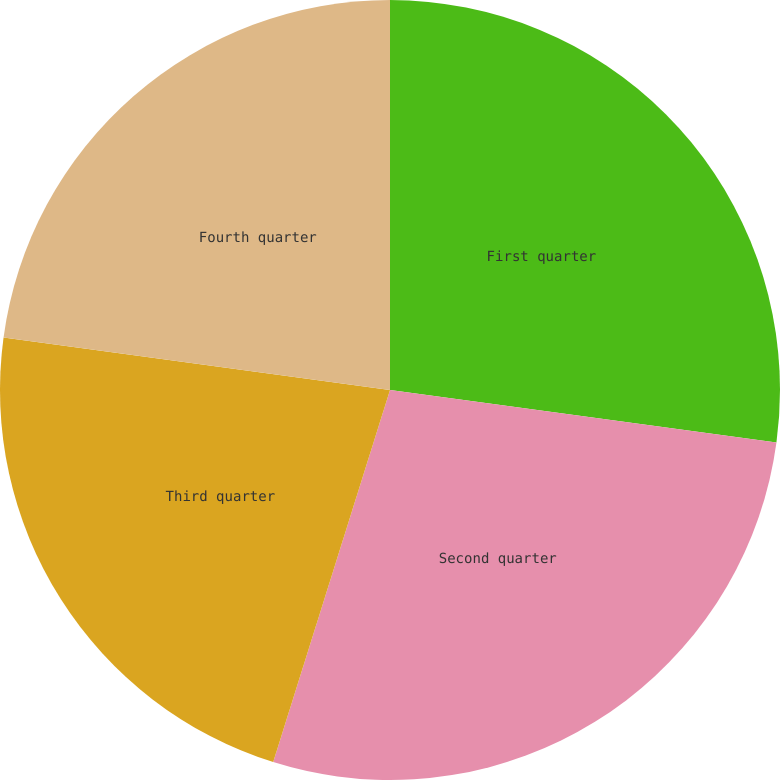<chart> <loc_0><loc_0><loc_500><loc_500><pie_chart><fcel>First quarter<fcel>Second quarter<fcel>Third quarter<fcel>Fourth quarter<nl><fcel>27.15%<fcel>27.69%<fcel>22.31%<fcel>22.85%<nl></chart> 